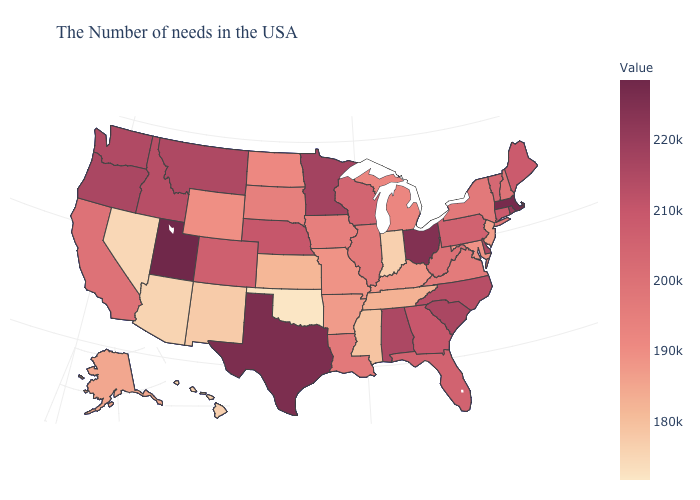Which states hav the highest value in the MidWest?
Quick response, please. Ohio. Which states have the lowest value in the USA?
Keep it brief. Oklahoma. Does Kentucky have the lowest value in the USA?
Concise answer only. No. Among the states that border Washington , which have the highest value?
Short answer required. Oregon. Among the states that border Virginia , which have the highest value?
Answer briefly. North Carolina. 